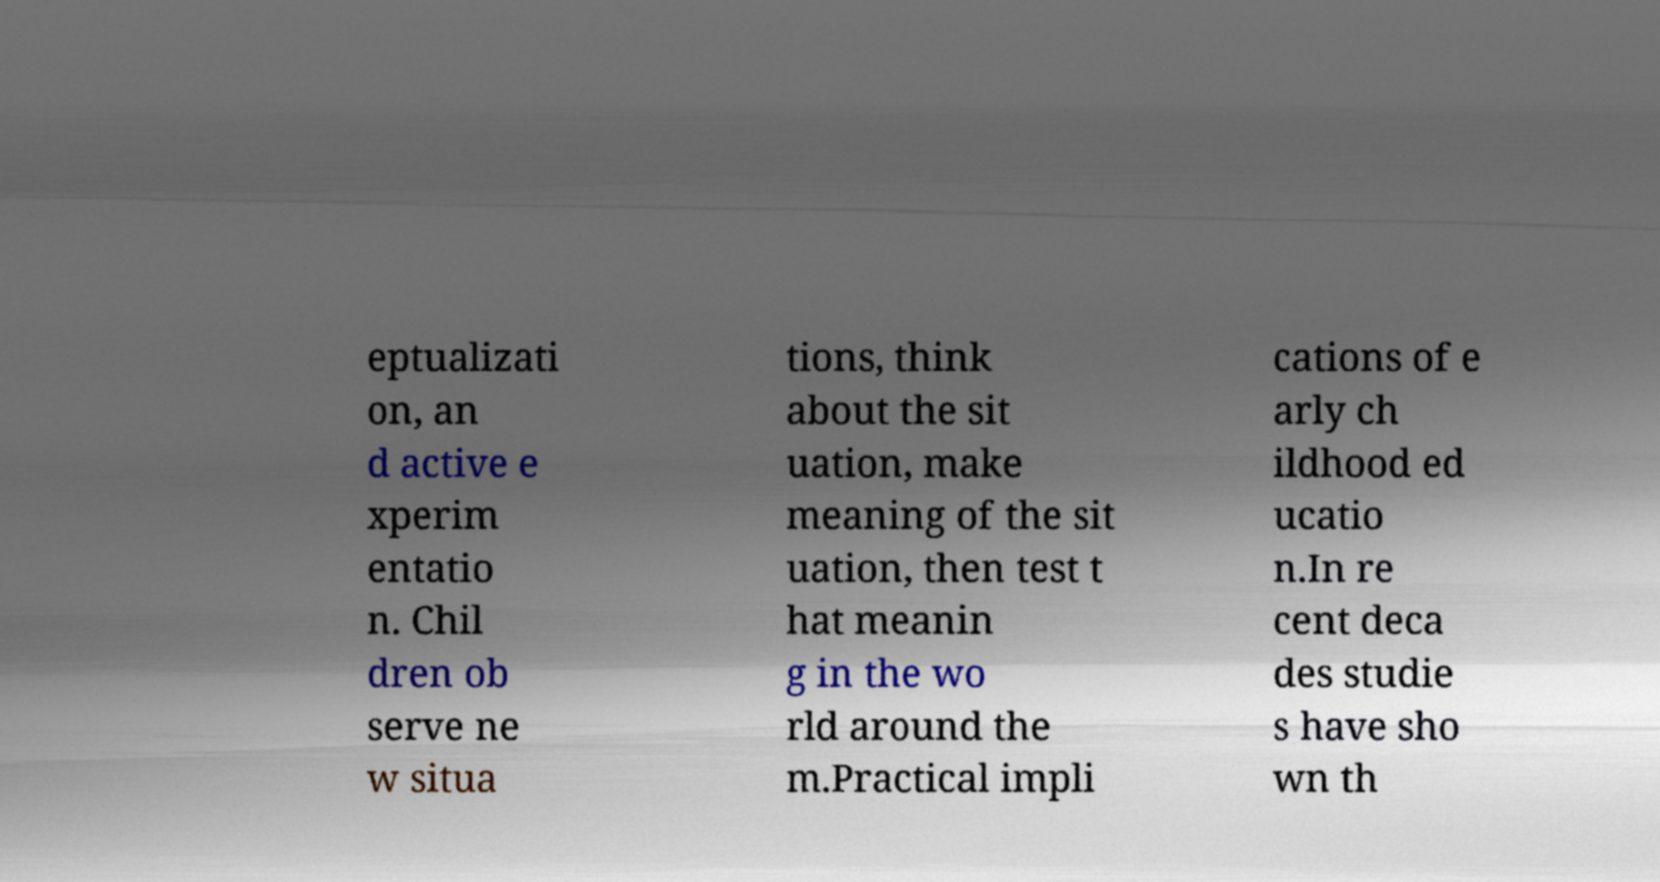Could you extract and type out the text from this image? eptualizati on, an d active e xperim entatio n. Chil dren ob serve ne w situa tions, think about the sit uation, make meaning of the sit uation, then test t hat meanin g in the wo rld around the m.Practical impli cations of e arly ch ildhood ed ucatio n.In re cent deca des studie s have sho wn th 